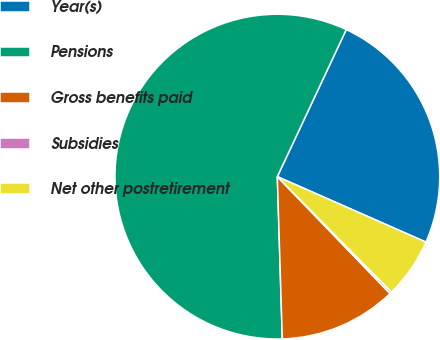Convert chart. <chart><loc_0><loc_0><loc_500><loc_500><pie_chart><fcel>Year(s)<fcel>Pensions<fcel>Gross benefits paid<fcel>Subsidies<fcel>Net other postretirement<nl><fcel>24.63%<fcel>57.47%<fcel>11.72%<fcel>0.2%<fcel>5.99%<nl></chart> 